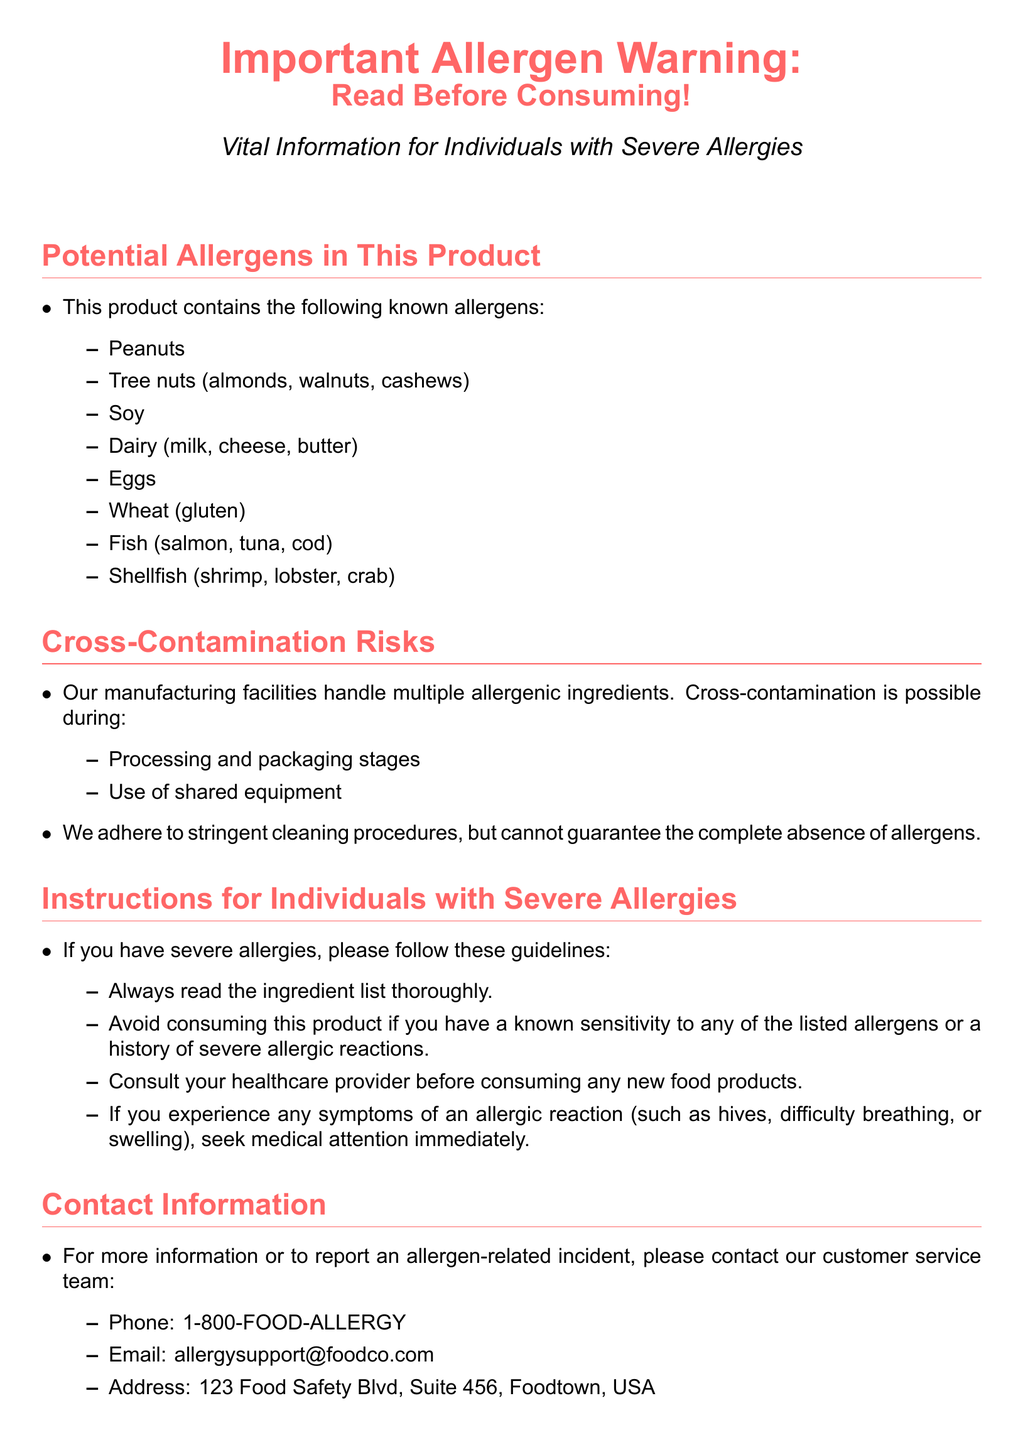What are the known allergens in this product? The known allergens are listed under "Potential Allergens in This Product," specifying various ingredients like peanuts and dairy.
Answer: Peanuts, Tree nuts, Soy, Dairy, Eggs, Wheat, Fish, Shellfish How many allergens are specifically mentioned? The document lists a total of eight allergens under the "Potential Allergens" section.
Answer: Eight What should individuals with severe allergies do before consuming this product? The instructions for individuals with severe allergies highlight the need to read the ingredient list thoroughly.
Answer: Read the ingredient list What is a potential risk during manufacturing? The section on cross-contamination risks states that cross-contamination is possible during processing and packaging stages.
Answer: Cross-contamination What is the contact phone number for allergen-related incidents? The contact information section provides a customer service phone number for reporting incidents.
Answer: 1-800-FOOD-ALLERGY What must individuals do if they experience symptoms of an allergic reaction? The document advises seeking medical attention immediately for any symptoms of an allergic reaction.
Answer: Seek medical attention What items are mentioned as shared equipment risks? The cross-contamination section mentions that processing and packaging stages use shared equipment as a risk factor.
Answer: Shared equipment Which allergen group includes almonds and walnuts? The document classifies tree nuts, including specific examples like almonds and walnuts, as allergens.
Answer: Tree nuts 